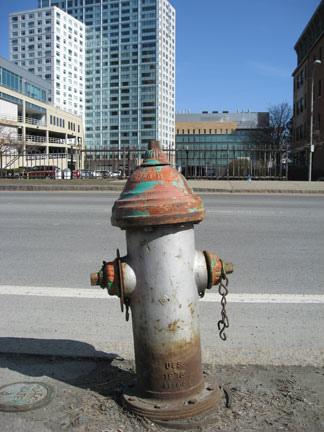What is the last number on the fire hydrant?
Short answer required. 5. What letter is written in black on the side of the hydrant?
Be succinct. None. How old is this fire hydrant?
Short answer required. Very old. How many different colors are on the fire hydrant?
Concise answer only. 3. Is this city clean?
Give a very brief answer. Yes. What color is the hydrant?
Answer briefly. Gray. How many chains are there?
Quick response, please. 1. Is the fire hydrant in the city?
Short answer required. Yes. What color is the top of the fire hydrant?
Quick response, please. Green. How many faucets are open?
Quick response, please. 0. 